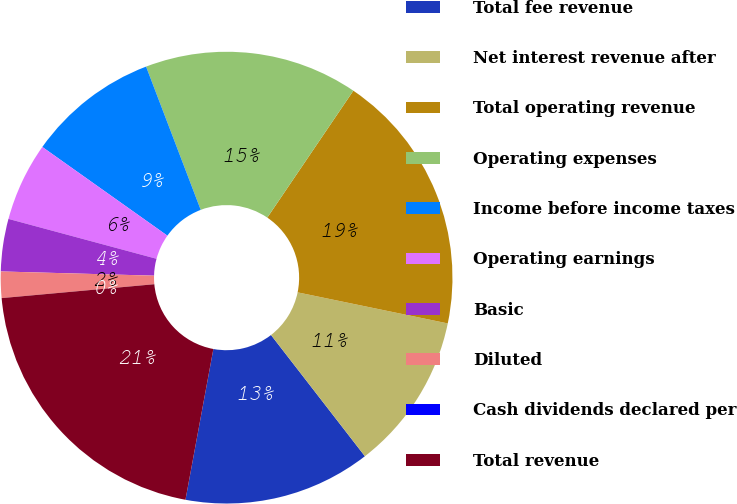<chart> <loc_0><loc_0><loc_500><loc_500><pie_chart><fcel>Total fee revenue<fcel>Net interest revenue after<fcel>Total operating revenue<fcel>Operating expenses<fcel>Income before income taxes<fcel>Operating earnings<fcel>Basic<fcel>Diluted<fcel>Cash dividends declared per<fcel>Total revenue<nl><fcel>13.4%<fcel>11.26%<fcel>18.76%<fcel>15.28%<fcel>9.38%<fcel>5.63%<fcel>3.75%<fcel>1.88%<fcel>0.0%<fcel>20.64%<nl></chart> 